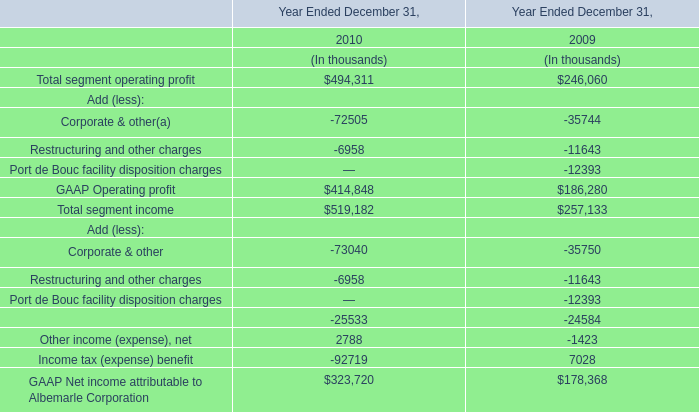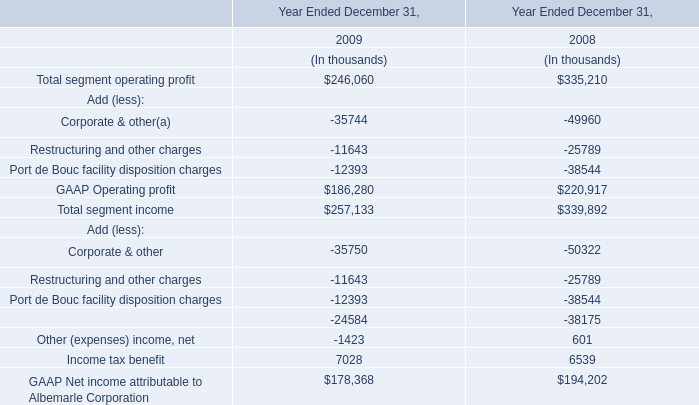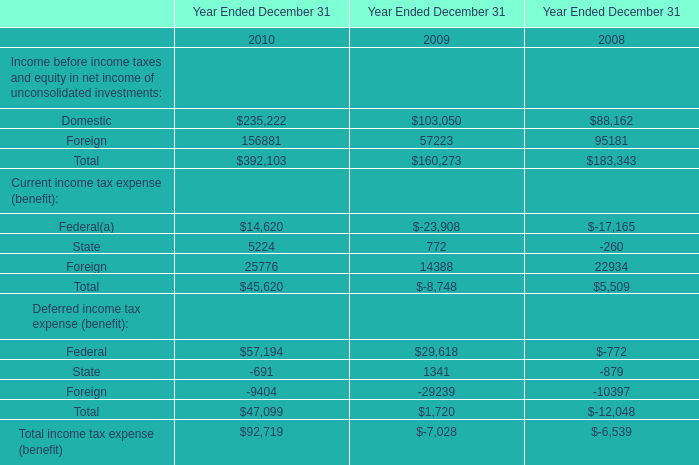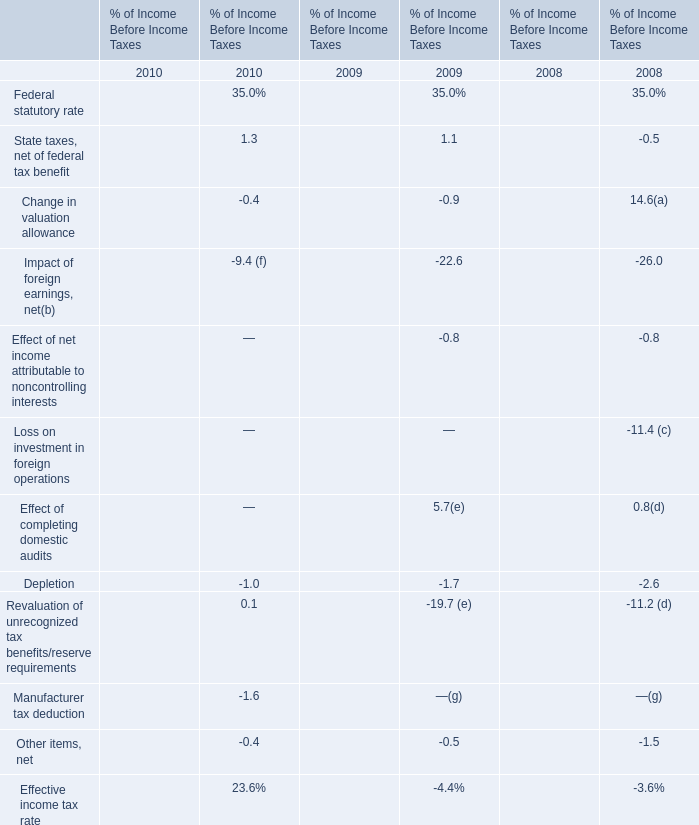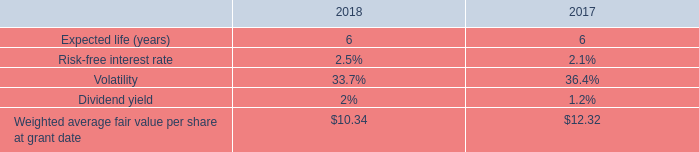What's the average of Federal and State and Foreign in Current income tax expense in 2010? 
Computations: (45620 / 3)
Answer: 15206.66667. 